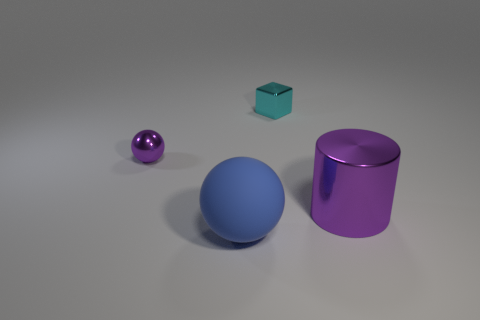Add 3 large metallic cylinders. How many objects exist? 7 Subtract all cubes. How many objects are left? 3 Subtract all red spheres. Subtract all red cylinders. How many spheres are left? 2 Subtract all small shiny blocks. Subtract all tiny things. How many objects are left? 1 Add 4 big metallic cylinders. How many big metallic cylinders are left? 5 Add 3 big blue objects. How many big blue objects exist? 4 Subtract 0 green balls. How many objects are left? 4 